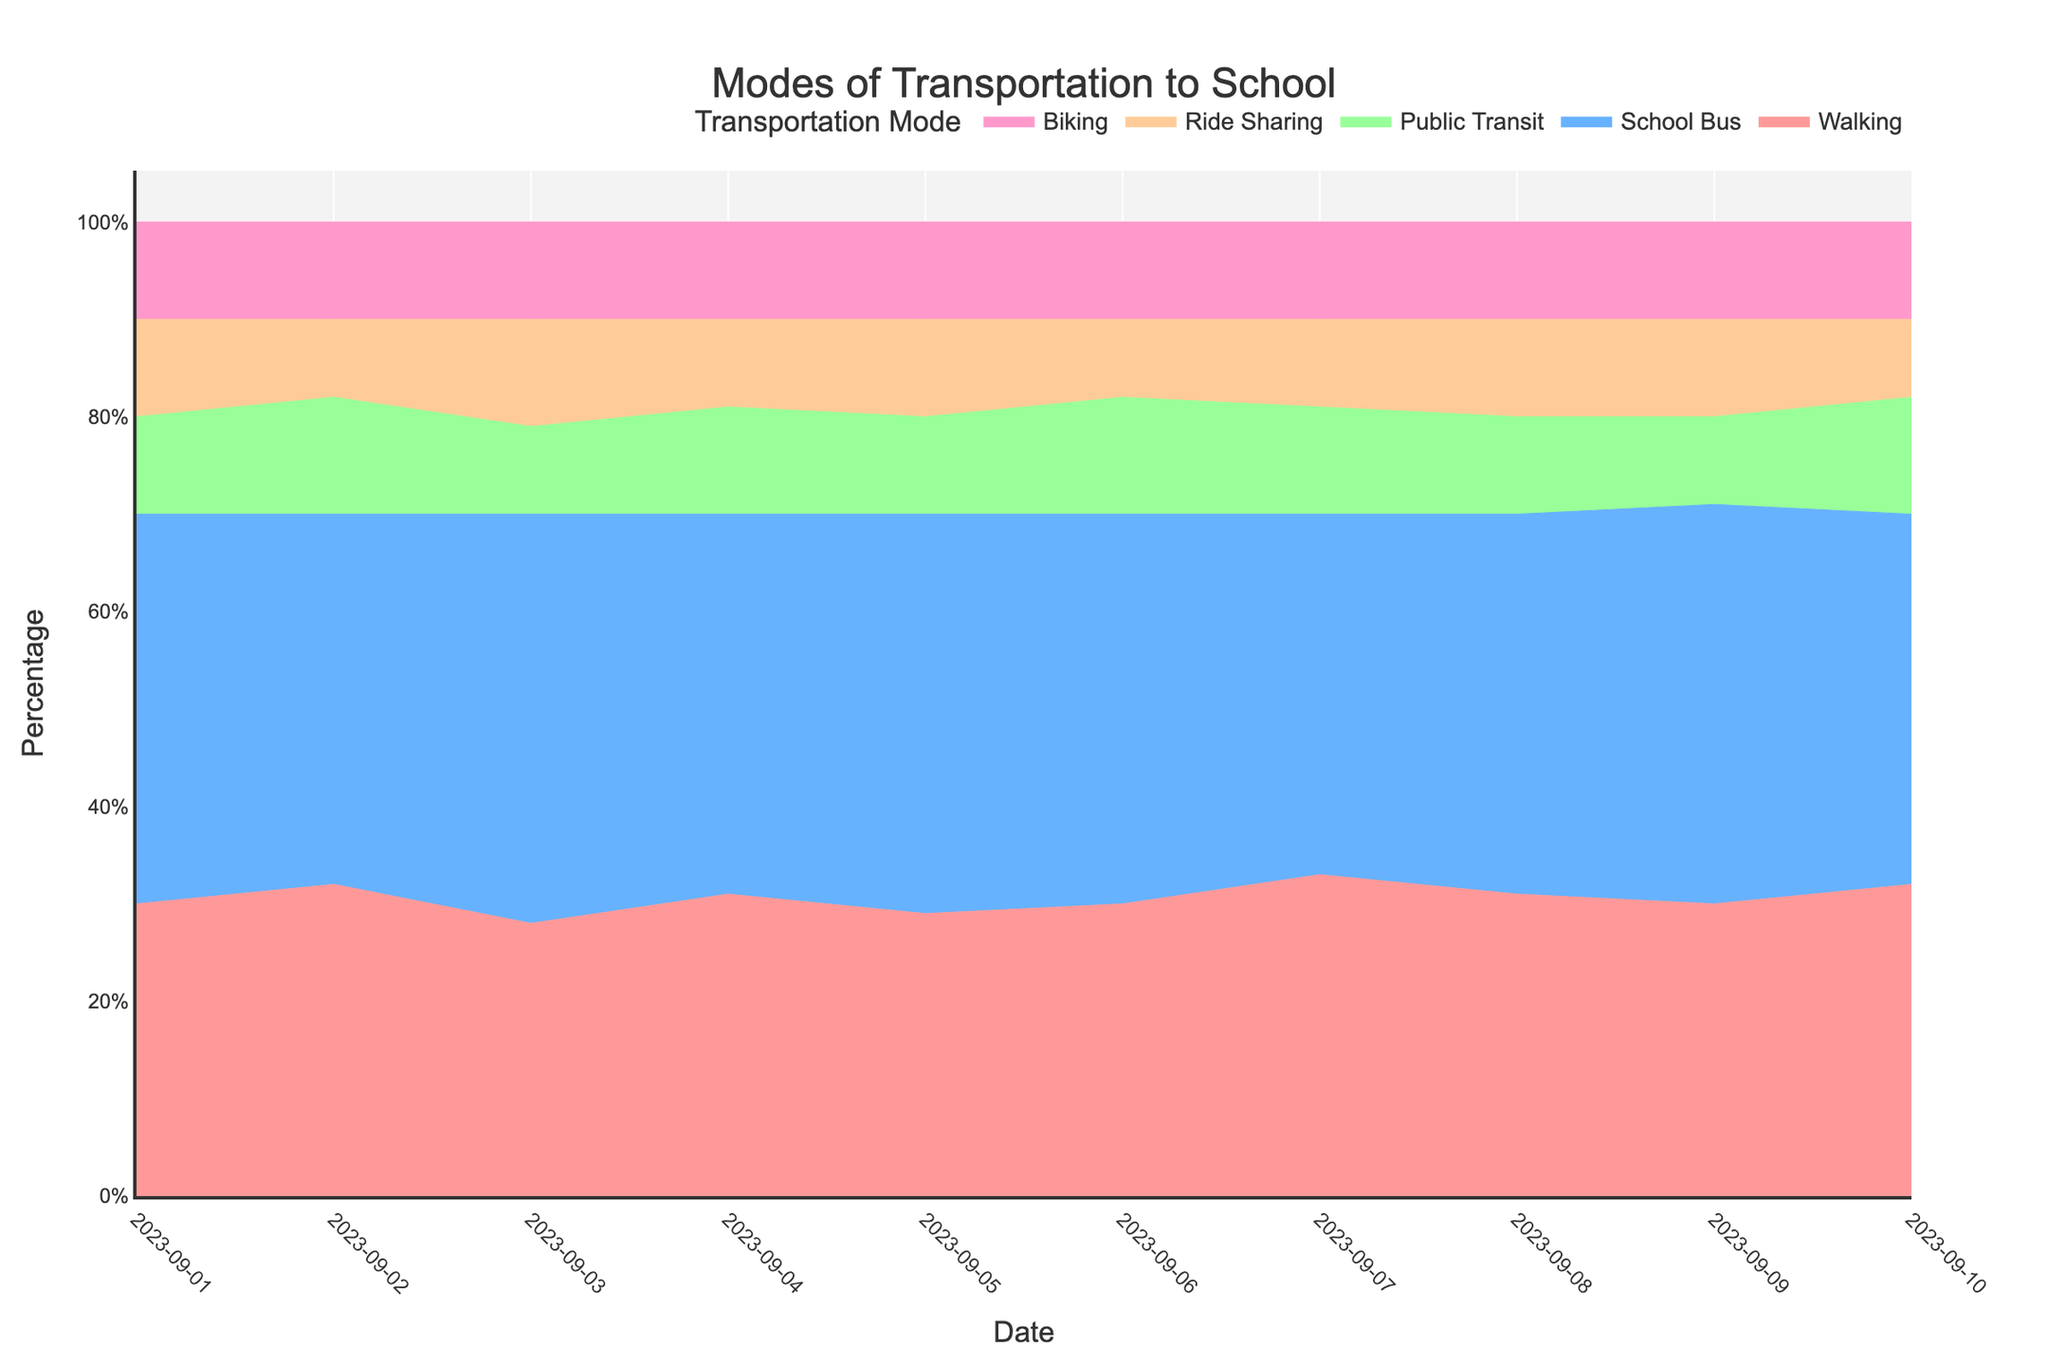What is the title of the chart? The title of a chart is usually placed at the top and serves as a descriptive heading for the chart. You can see it at the top of the figure.
Answer: Modes of Transportation to School What are the categories of transportation modes shown in the chart? The categories of transportation modes are typically represented by different segments or areas in the chart. The legend or labels near the chart usually provide this information.
Answer: Walking, School Bus, Public Transit, Ride Sharing, Biking How many days are represented in the chart? The x-axis of the chart usually represents the timeline and shows different dates. By counting the distinct dates along the x-axis, you can determine the number of days represented.
Answer: 10 Which transportation mode has the smallest percentage on 2023-09-03? To find the smallest percentage, look at the chart for the specified date and identify the segment that has the smallest area. The hover information or legend may also help identify the value.
Answer: Public Transit On which date does Ride Sharing have the highest percentage? By examining the area corresponding to Ride Sharing across different dates, you can identify the date where the percentage is the highest. This can be verified by looking at the peak point for Ride Sharing in the chart.
Answer: 2023-09-03 What was the percentage of students walking to school on 2023-09-04? To find the percentage for Walking on a specific date, locate the corresponding segment in the chart for that date. The hover information or respective segment will indicate the percentage.
Answer: 31% Which transportation mode shows the least variation in percentage over the period? By observing the changes in the areas of different segments over the timeline, you can identify which segment appears to have the most consistent area size, indicating least variation.
Answer: Biking How does the percentage of students using Public Transit on 2023-09-06 compare to 2023-09-07? Look at the area representing Public Transit for both dates and compare their heights. This can also be checked via hover information to see the exact percentages.
Answer: 12% on 2023-09-06, 11% on 2023-09-07 What is the overall trend for students taking the School Bus? Increasing, decreasing, or stable? By examining the area for School Bus over the timeline, you can assess whether the area is generally growing, shrinking, or staying the same. Check if the trend is consistently upward, downward, or level.
Answer: Stable Which transportation mode had the highest percentage on average over the 10 days? To find the average percentage over 10 days, sum up the percentages for each day for each transportation mode and then divide by 10. Compare the averages for all modes to determine the highest one.
Answer: School Bus 